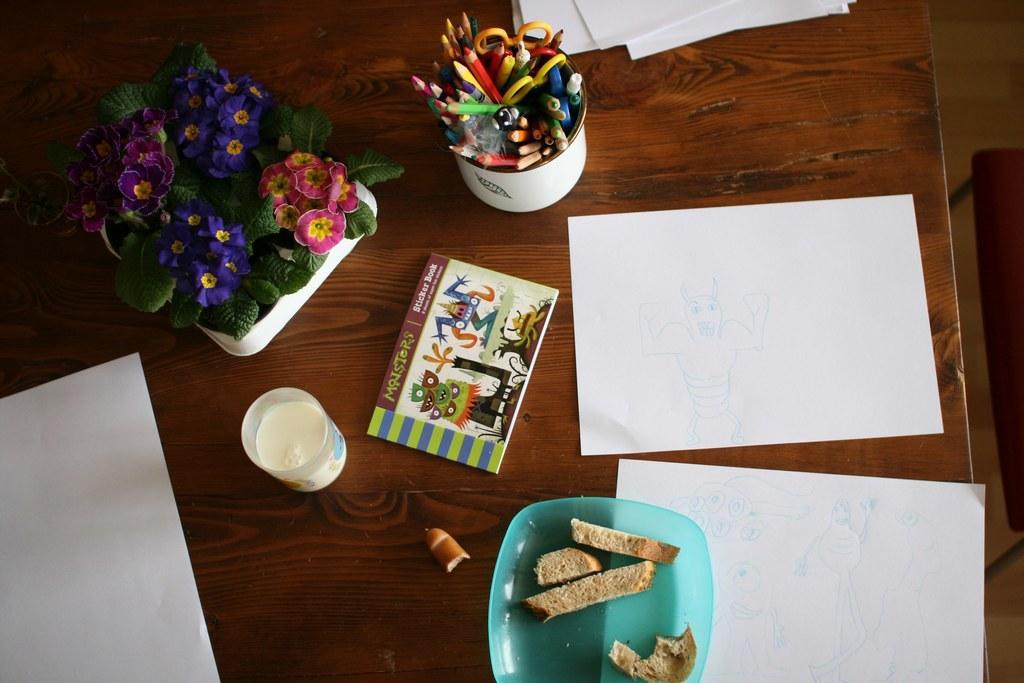How would you summarize this image in a sentence or two? In this image there is a table, on that table there are papers, cups in that cups there are pencils and a flower vase, a plate in that plate there is a food item and a glass with milk. 